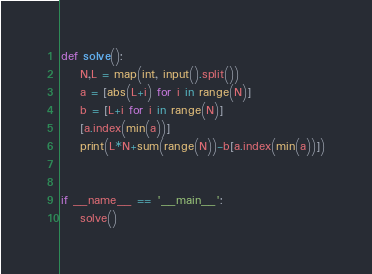Convert code to text. <code><loc_0><loc_0><loc_500><loc_500><_Python_>def solve():
    N,L = map(int, input().split())
    a = [abs(L+i) for i in range(N)]
    b = [L+i for i in range(N)]
    [a.index(min(a))]
    print(L*N+sum(range(N))-b[a.index(min(a))])
    

if __name__ == '__main__':
    solve()</code> 